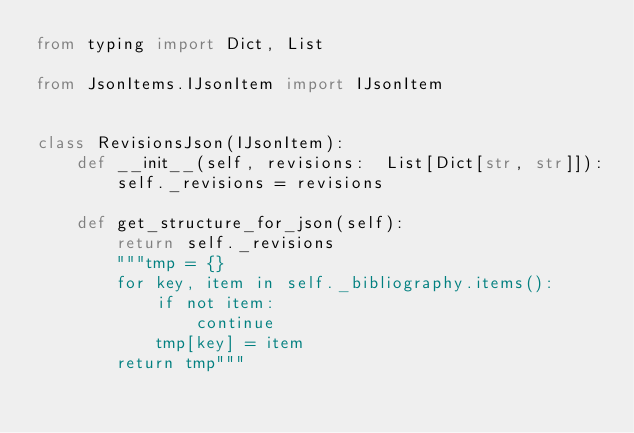Convert code to text. <code><loc_0><loc_0><loc_500><loc_500><_Python_>from typing import Dict, List

from JsonItems.IJsonItem import IJsonItem


class RevisionsJson(IJsonItem):
    def __init__(self, revisions:  List[Dict[str, str]]):
        self._revisions = revisions

    def get_structure_for_json(self):
        return self._revisions
        """tmp = {}
        for key, item in self._bibliography.items():
            if not item:
                continue
            tmp[key] = item
        return tmp"""
</code> 